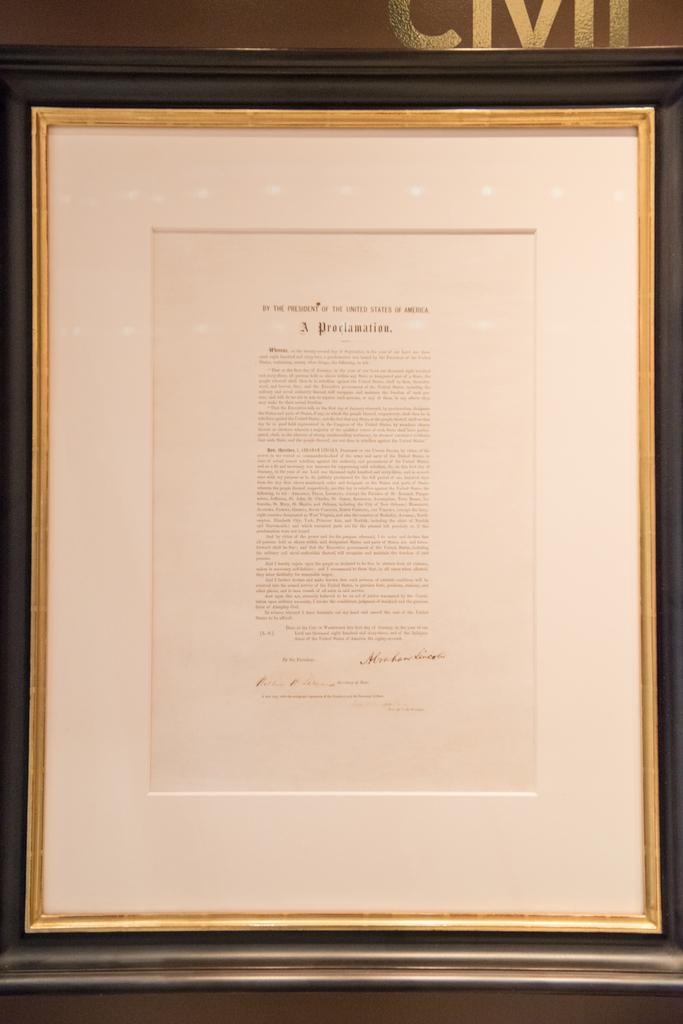<image>
Create a compact narrative representing the image presented. A Proclamation by the President of the United States of America. 